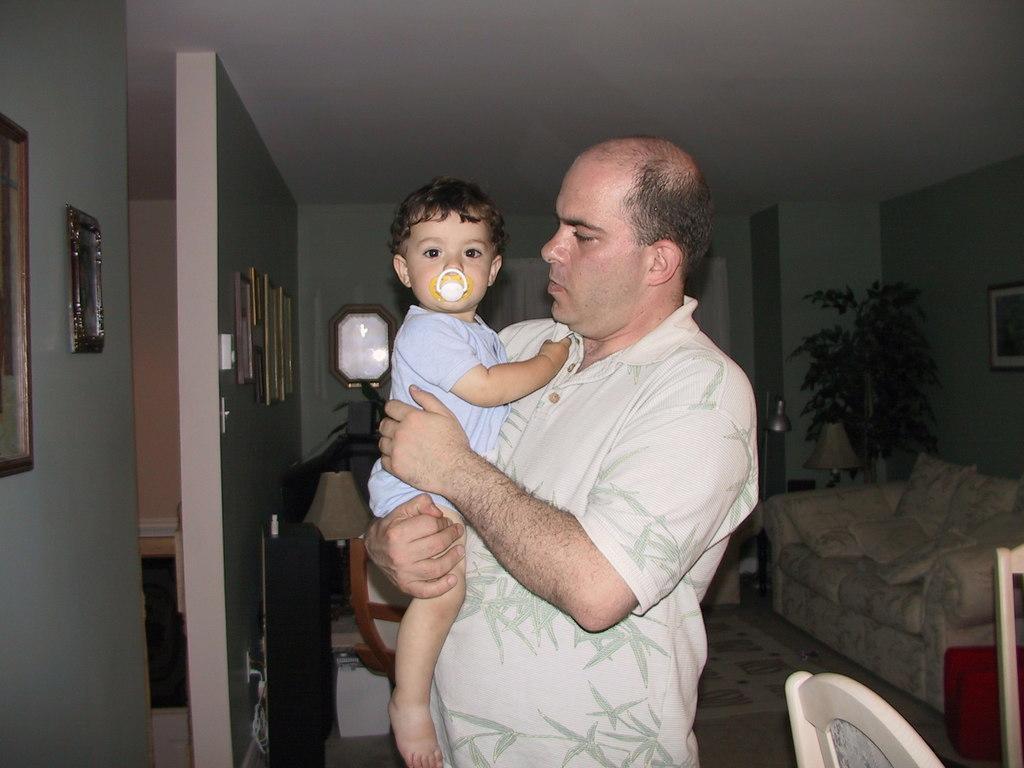Describe this image in one or two sentences. In the image we can see a man standing wearing clothes and the man is holding a baby. Here we can see the plant, sofa, chairs and the floor. Here we can see frames stick to the wall and the lamp. 